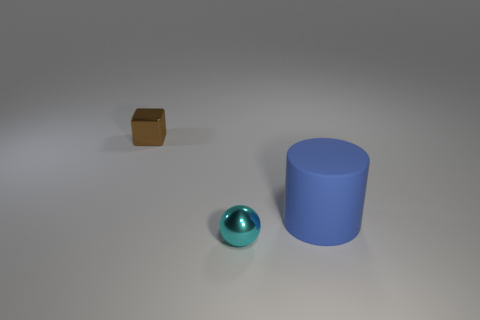Is there a blue thing made of the same material as the cylinder?
Ensure brevity in your answer.  No. What color is the tiny metal cube?
Your answer should be compact. Brown. There is a metallic thing in front of the tiny metallic block; is its shape the same as the brown object?
Ensure brevity in your answer.  No. There is a big blue rubber object to the right of the tiny thing that is behind the metal thing in front of the large blue cylinder; what is its shape?
Your answer should be compact. Cylinder. What is the tiny object that is behind the large blue cylinder made of?
Make the answer very short. Metal. The metal sphere that is the same size as the block is what color?
Ensure brevity in your answer.  Cyan. How many other objects are the same shape as the brown thing?
Provide a short and direct response. 0. Do the blue rubber cylinder and the cyan metallic object have the same size?
Give a very brief answer. No. Are there more large blue matte things in front of the big blue rubber object than rubber cylinders that are behind the brown shiny object?
Offer a very short reply. No. What number of other things are there of the same size as the cyan object?
Provide a short and direct response. 1. 